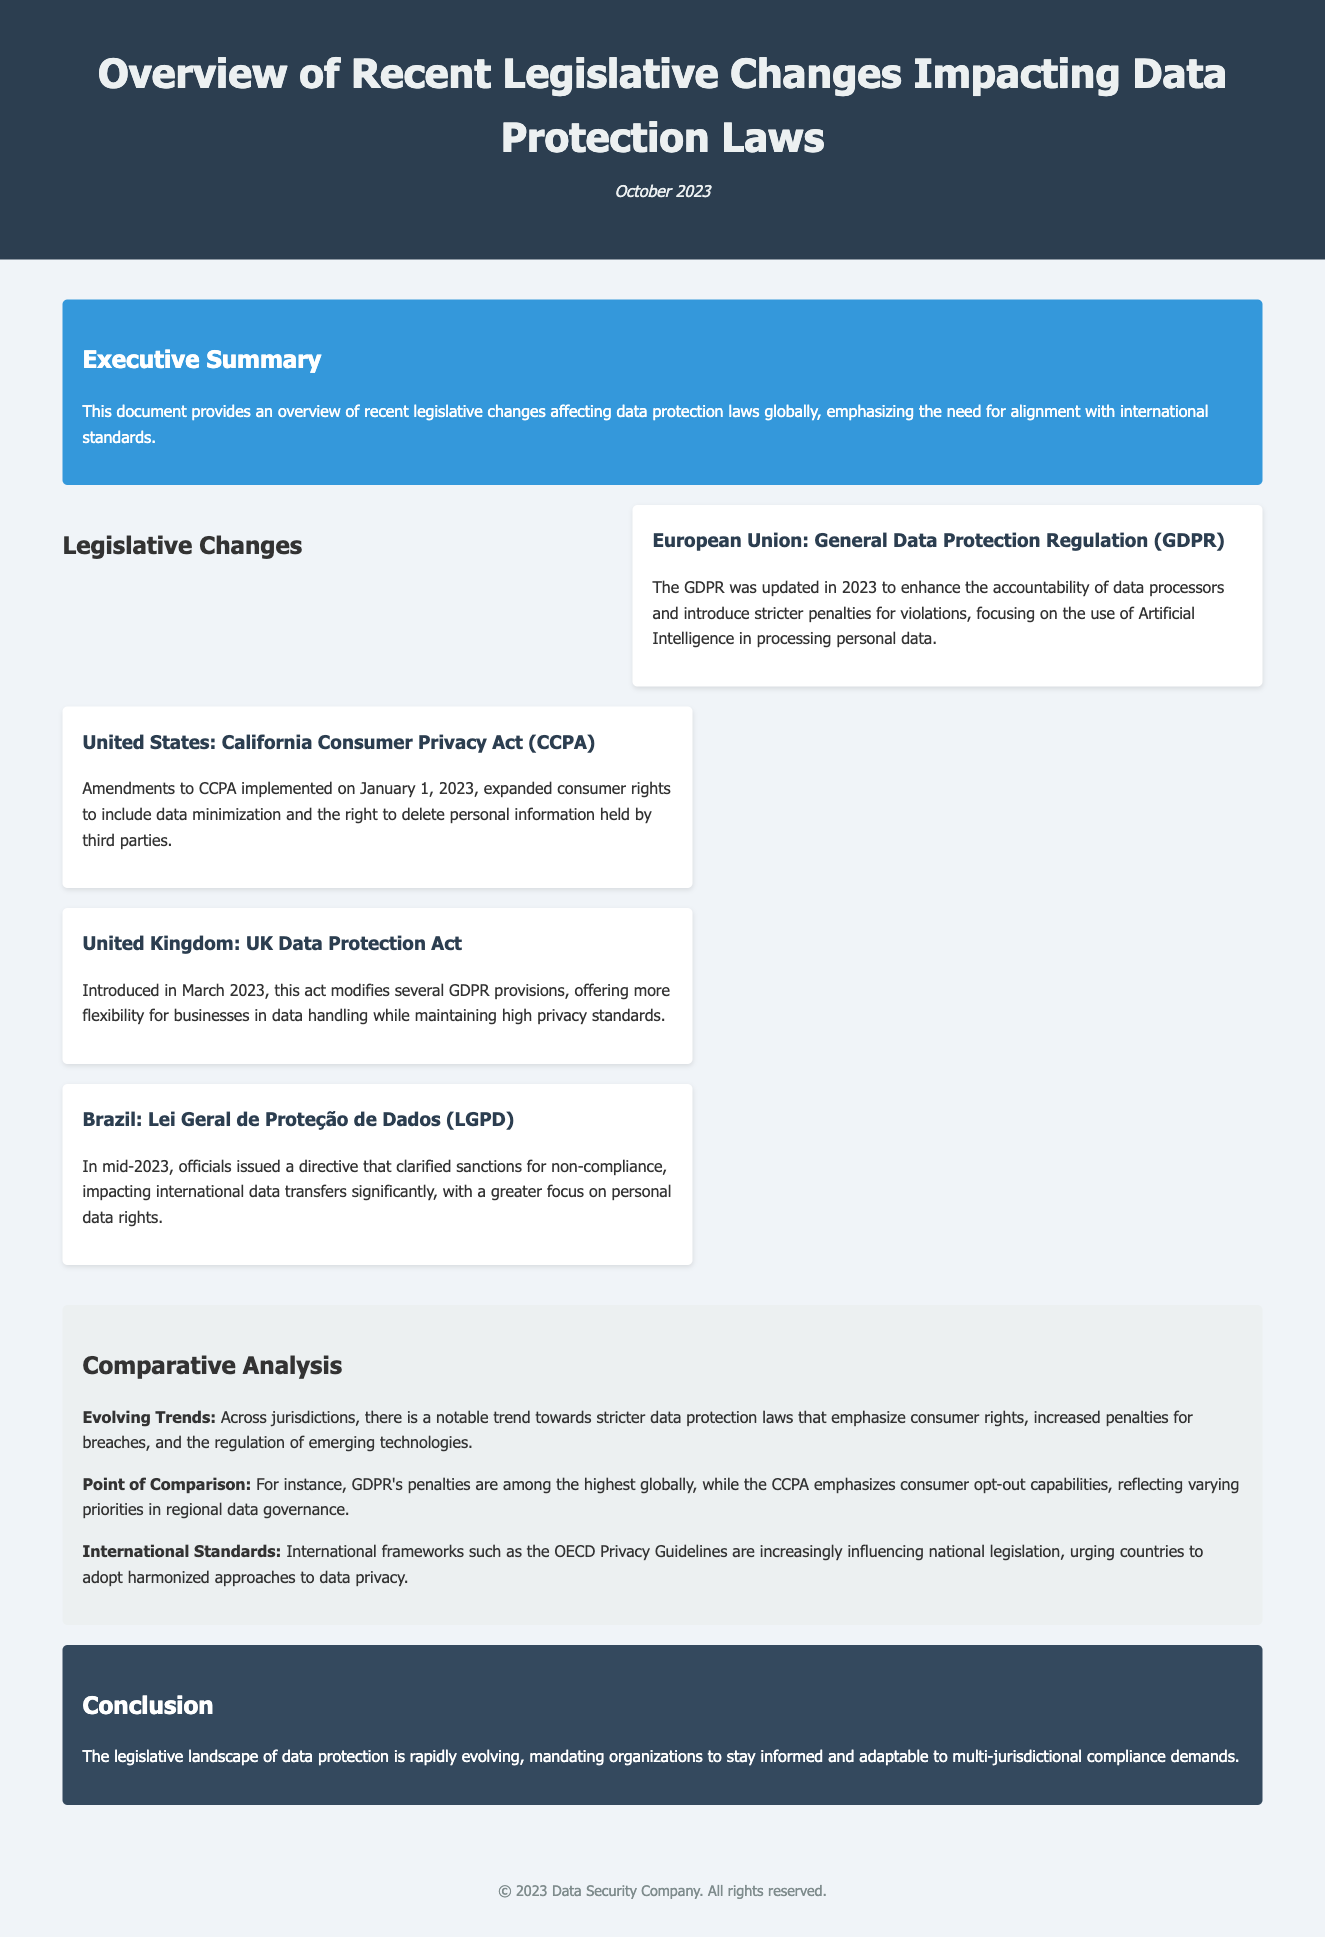What are the main legislative changes in 2023? The document mentions several key legislative changes including updates to the GDPR, amendments to the CCPA, the introduction of the UK Data Protection Act, and clarifications to the LGPD.
Answer: GDPR, CCPA, UK Data Protection Act, LGPD How is the GDPR updated in 2023? The GDPR was updated in 2023 to enhance the accountability of data processors and introduce stricter penalties for violations.
Answer: Enhanced accountability, stricter penalties What rights were expanded under the CCPA in 2023? The amendments to the CCPA expanded consumer rights to include data minimization and the right to delete personal information held by third parties.
Answer: Data minimization, right to delete What is a point of comparison mentioned in the document? The document compares GDPR's penalties and the CCPA's emphasis on consumer opt-out capabilities to reflect varying priorities in data governance.
Answer: GDPR penalties vs. CCPA opt-out What international framework influences national legislation? The OECD Privacy Guidelines are mentioned as influencing national legislation, urging countries to adopt harmonized approaches to data privacy.
Answer: OECD Privacy Guidelines What is the primary focus of Brazil's LGPD directive issued in 2023? The directive clarified sanctions for non-compliance, significantly impacting international data transfers and greater focus on personal data rights.
Answer: Clarified sanctions, personal data rights How does the document describe the evolving trends in data protection laws? The document states there is a trend towards stricter data protection laws that emphasize consumer rights, increased penalties for breaches, and emerging technologies regulation.
Answer: Stricter laws, consumer rights emphasis What is the publication date of the document? The document was published in October 2023, as indicated in the header section.
Answer: October 2023 